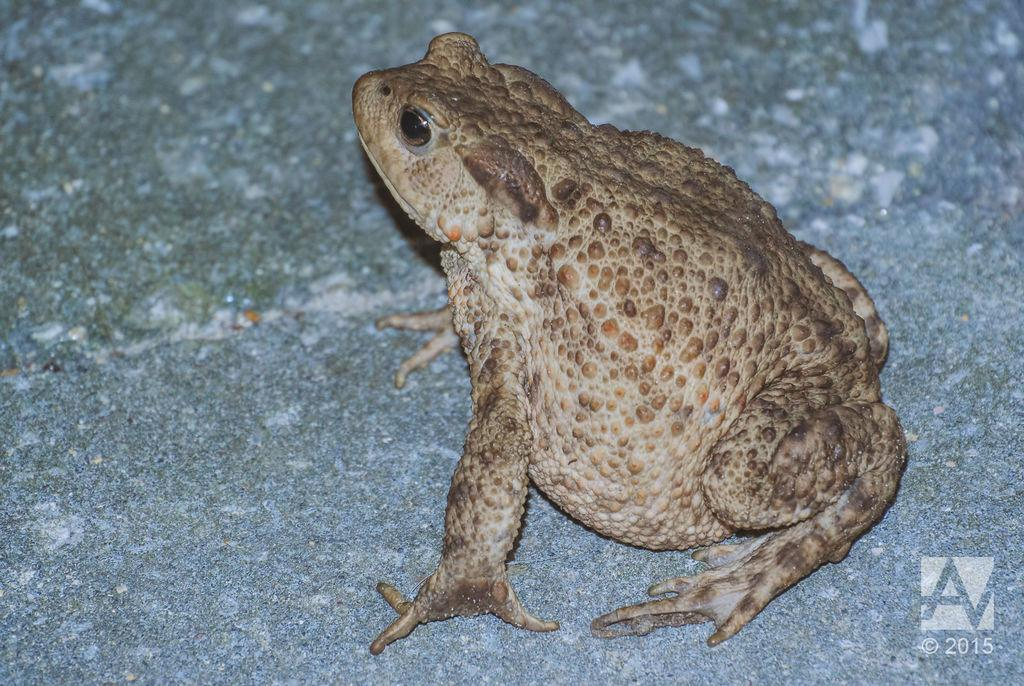What is the main subject in the center of the image? There is a frog in the center of the image. What type of knife is the frog using to brush its teeth in the sink? There is no knife, toothbrush, or sink present in the image; it only features a frog. 